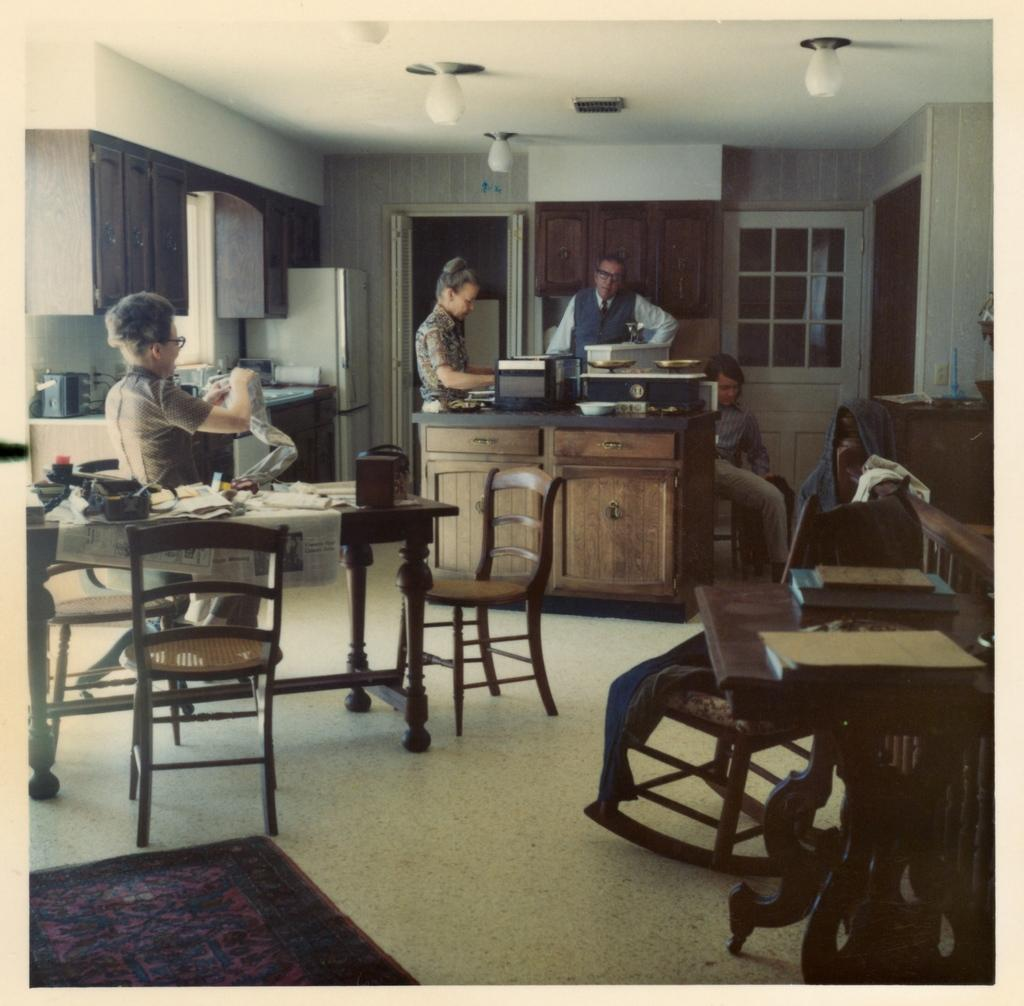What can be seen in the image related to storage? There is a cupboard and a refrigerator in the image. What furniture is present in the image? There is a table, a chair, and a door in the image. What can be seen in the image related to lighting? There is a light in the image. What can be seen in the image related to cooking? There is a stove in the image. What can be seen in the image related to ventilation or natural light? There is a window in the image. Can you tell me how many times the spark turns around in the image? There is no spark present in the image. What type of creature runs across the table in the image? There is no creature running across the table in the image. 